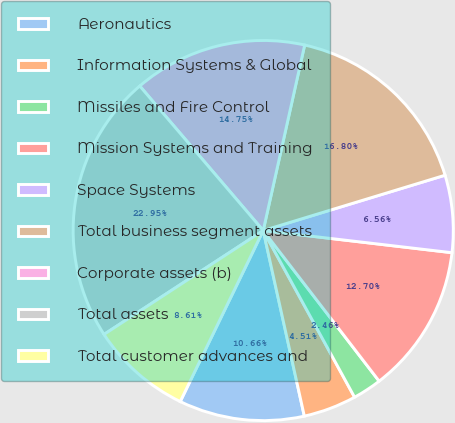Convert chart. <chart><loc_0><loc_0><loc_500><loc_500><pie_chart><fcel>Aeronautics<fcel>Information Systems & Global<fcel>Missiles and Fire Control<fcel>Mission Systems and Training<fcel>Space Systems<fcel>Total business segment assets<fcel>Corporate assets (b)<fcel>Total assets<fcel>Total customer advances and<nl><fcel>10.66%<fcel>4.51%<fcel>2.46%<fcel>12.7%<fcel>6.56%<fcel>16.8%<fcel>14.75%<fcel>22.95%<fcel>8.61%<nl></chart> 